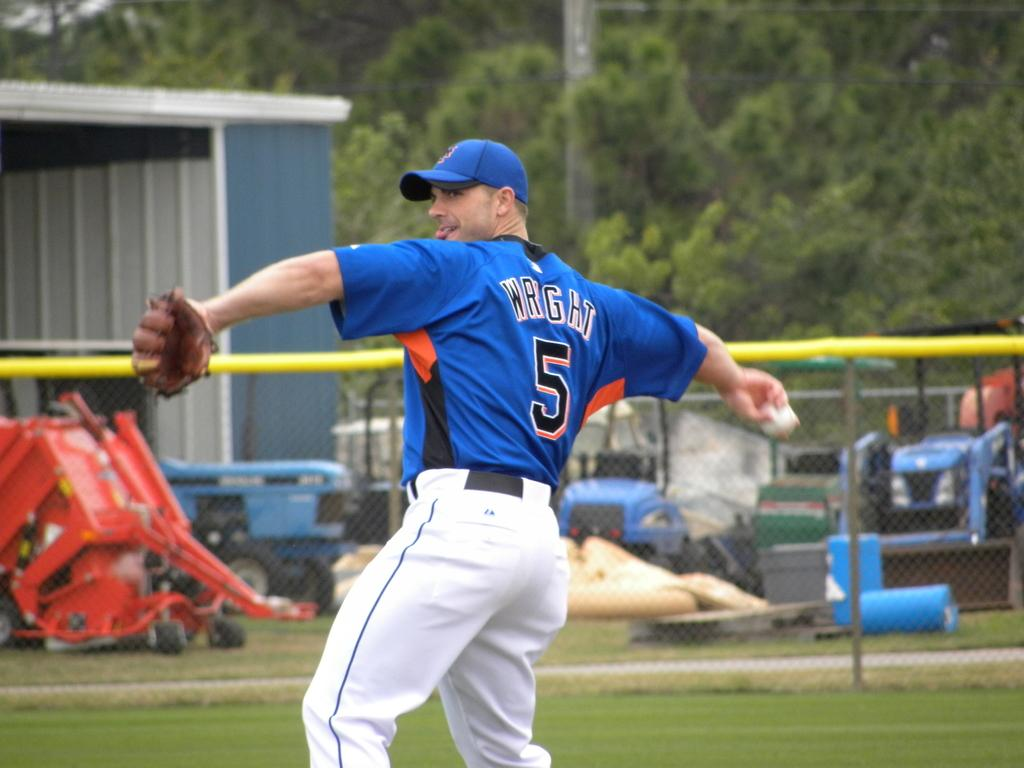What can be seen in large quantities in the image? There are many trees in the image. What else is present in the image besides trees? There are vehicles and a person holding a ball in the image. Where is the shed located in the image? The shed is at the right side of the image. What color is the daughter's skin in the image? There is no daughter present in the image. What is the limit of the vehicles in the image? The provided facts do not mention any limit on the vehicles in the image. 